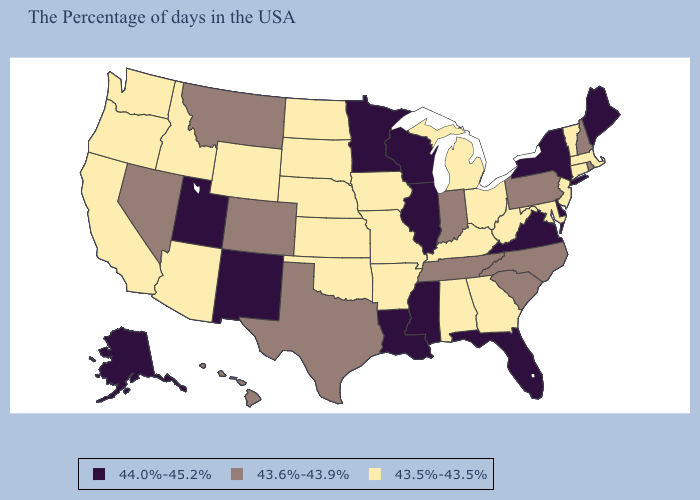Does the first symbol in the legend represent the smallest category?
Quick response, please. No. Among the states that border Washington , which have the lowest value?
Quick response, please. Idaho, Oregon. What is the lowest value in the USA?
Quick response, please. 43.5%-43.5%. What is the value of Wyoming?
Answer briefly. 43.5%-43.5%. What is the lowest value in the South?
Concise answer only. 43.5%-43.5%. Which states have the highest value in the USA?
Write a very short answer. Maine, New York, Delaware, Virginia, Florida, Wisconsin, Illinois, Mississippi, Louisiana, Minnesota, New Mexico, Utah, Alaska. What is the value of Florida?
Be succinct. 44.0%-45.2%. Does Georgia have a higher value than Alabama?
Give a very brief answer. No. What is the value of Missouri?
Answer briefly. 43.5%-43.5%. Does New York have a higher value than Pennsylvania?
Answer briefly. Yes. Is the legend a continuous bar?
Concise answer only. No. Does Texas have the same value as Massachusetts?
Be succinct. No. Does the map have missing data?
Write a very short answer. No. What is the highest value in the USA?
Quick response, please. 44.0%-45.2%. 